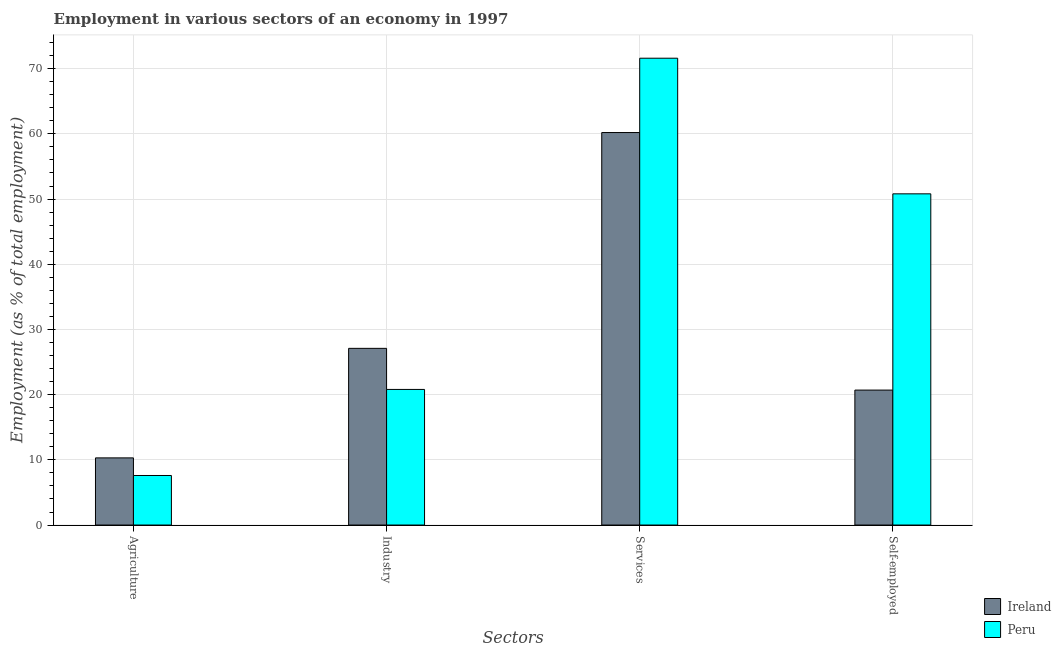Are the number of bars per tick equal to the number of legend labels?
Your answer should be very brief. Yes. How many bars are there on the 4th tick from the left?
Keep it short and to the point. 2. What is the label of the 3rd group of bars from the left?
Your answer should be compact. Services. What is the percentage of workers in agriculture in Peru?
Your answer should be very brief. 7.6. Across all countries, what is the maximum percentage of workers in industry?
Provide a short and direct response. 27.1. Across all countries, what is the minimum percentage of workers in industry?
Offer a terse response. 20.8. In which country was the percentage of workers in services maximum?
Your response must be concise. Peru. What is the total percentage of self employed workers in the graph?
Your answer should be very brief. 71.5. What is the difference between the percentage of self employed workers in Peru and that in Ireland?
Provide a short and direct response. 30.1. What is the difference between the percentage of self employed workers in Peru and the percentage of workers in services in Ireland?
Make the answer very short. -9.4. What is the average percentage of workers in services per country?
Make the answer very short. 65.9. What is the difference between the percentage of workers in services and percentage of workers in agriculture in Ireland?
Provide a succinct answer. 49.9. What is the ratio of the percentage of workers in agriculture in Peru to that in Ireland?
Your response must be concise. 0.74. What is the difference between the highest and the second highest percentage of workers in agriculture?
Ensure brevity in your answer.  2.7. What is the difference between the highest and the lowest percentage of workers in agriculture?
Ensure brevity in your answer.  2.7. What does the 1st bar from the left in Agriculture represents?
Ensure brevity in your answer.  Ireland. What does the 1st bar from the right in Industry represents?
Provide a succinct answer. Peru. How many bars are there?
Ensure brevity in your answer.  8. How many countries are there in the graph?
Your answer should be compact. 2. Are the values on the major ticks of Y-axis written in scientific E-notation?
Make the answer very short. No. Does the graph contain any zero values?
Provide a succinct answer. No. What is the title of the graph?
Give a very brief answer. Employment in various sectors of an economy in 1997. What is the label or title of the X-axis?
Give a very brief answer. Sectors. What is the label or title of the Y-axis?
Provide a short and direct response. Employment (as % of total employment). What is the Employment (as % of total employment) of Ireland in Agriculture?
Your answer should be compact. 10.3. What is the Employment (as % of total employment) in Peru in Agriculture?
Make the answer very short. 7.6. What is the Employment (as % of total employment) of Ireland in Industry?
Provide a succinct answer. 27.1. What is the Employment (as % of total employment) in Peru in Industry?
Offer a very short reply. 20.8. What is the Employment (as % of total employment) of Ireland in Services?
Ensure brevity in your answer.  60.2. What is the Employment (as % of total employment) in Peru in Services?
Your answer should be very brief. 71.6. What is the Employment (as % of total employment) in Ireland in Self-employed?
Keep it short and to the point. 20.7. What is the Employment (as % of total employment) in Peru in Self-employed?
Ensure brevity in your answer.  50.8. Across all Sectors, what is the maximum Employment (as % of total employment) in Ireland?
Your response must be concise. 60.2. Across all Sectors, what is the maximum Employment (as % of total employment) of Peru?
Offer a very short reply. 71.6. Across all Sectors, what is the minimum Employment (as % of total employment) of Ireland?
Your answer should be very brief. 10.3. Across all Sectors, what is the minimum Employment (as % of total employment) in Peru?
Provide a succinct answer. 7.6. What is the total Employment (as % of total employment) of Ireland in the graph?
Make the answer very short. 118.3. What is the total Employment (as % of total employment) of Peru in the graph?
Provide a short and direct response. 150.8. What is the difference between the Employment (as % of total employment) of Ireland in Agriculture and that in Industry?
Provide a succinct answer. -16.8. What is the difference between the Employment (as % of total employment) in Peru in Agriculture and that in Industry?
Your answer should be very brief. -13.2. What is the difference between the Employment (as % of total employment) of Ireland in Agriculture and that in Services?
Your response must be concise. -49.9. What is the difference between the Employment (as % of total employment) in Peru in Agriculture and that in Services?
Your answer should be very brief. -64. What is the difference between the Employment (as % of total employment) in Ireland in Agriculture and that in Self-employed?
Provide a short and direct response. -10.4. What is the difference between the Employment (as % of total employment) of Peru in Agriculture and that in Self-employed?
Offer a very short reply. -43.2. What is the difference between the Employment (as % of total employment) in Ireland in Industry and that in Services?
Your answer should be compact. -33.1. What is the difference between the Employment (as % of total employment) of Peru in Industry and that in Services?
Ensure brevity in your answer.  -50.8. What is the difference between the Employment (as % of total employment) in Peru in Industry and that in Self-employed?
Offer a very short reply. -30. What is the difference between the Employment (as % of total employment) of Ireland in Services and that in Self-employed?
Provide a succinct answer. 39.5. What is the difference between the Employment (as % of total employment) of Peru in Services and that in Self-employed?
Your answer should be very brief. 20.8. What is the difference between the Employment (as % of total employment) in Ireland in Agriculture and the Employment (as % of total employment) in Peru in Services?
Your response must be concise. -61.3. What is the difference between the Employment (as % of total employment) in Ireland in Agriculture and the Employment (as % of total employment) in Peru in Self-employed?
Provide a short and direct response. -40.5. What is the difference between the Employment (as % of total employment) in Ireland in Industry and the Employment (as % of total employment) in Peru in Services?
Your answer should be very brief. -44.5. What is the difference between the Employment (as % of total employment) in Ireland in Industry and the Employment (as % of total employment) in Peru in Self-employed?
Ensure brevity in your answer.  -23.7. What is the difference between the Employment (as % of total employment) of Ireland in Services and the Employment (as % of total employment) of Peru in Self-employed?
Keep it short and to the point. 9.4. What is the average Employment (as % of total employment) of Ireland per Sectors?
Your response must be concise. 29.57. What is the average Employment (as % of total employment) in Peru per Sectors?
Make the answer very short. 37.7. What is the difference between the Employment (as % of total employment) of Ireland and Employment (as % of total employment) of Peru in Industry?
Your response must be concise. 6.3. What is the difference between the Employment (as % of total employment) of Ireland and Employment (as % of total employment) of Peru in Services?
Your response must be concise. -11.4. What is the difference between the Employment (as % of total employment) in Ireland and Employment (as % of total employment) in Peru in Self-employed?
Offer a very short reply. -30.1. What is the ratio of the Employment (as % of total employment) of Ireland in Agriculture to that in Industry?
Provide a succinct answer. 0.38. What is the ratio of the Employment (as % of total employment) of Peru in Agriculture to that in Industry?
Offer a terse response. 0.37. What is the ratio of the Employment (as % of total employment) in Ireland in Agriculture to that in Services?
Keep it short and to the point. 0.17. What is the ratio of the Employment (as % of total employment) in Peru in Agriculture to that in Services?
Make the answer very short. 0.11. What is the ratio of the Employment (as % of total employment) of Ireland in Agriculture to that in Self-employed?
Offer a terse response. 0.5. What is the ratio of the Employment (as % of total employment) of Peru in Agriculture to that in Self-employed?
Ensure brevity in your answer.  0.15. What is the ratio of the Employment (as % of total employment) in Ireland in Industry to that in Services?
Provide a succinct answer. 0.45. What is the ratio of the Employment (as % of total employment) of Peru in Industry to that in Services?
Offer a terse response. 0.29. What is the ratio of the Employment (as % of total employment) of Ireland in Industry to that in Self-employed?
Provide a succinct answer. 1.31. What is the ratio of the Employment (as % of total employment) in Peru in Industry to that in Self-employed?
Offer a terse response. 0.41. What is the ratio of the Employment (as % of total employment) of Ireland in Services to that in Self-employed?
Make the answer very short. 2.91. What is the ratio of the Employment (as % of total employment) of Peru in Services to that in Self-employed?
Give a very brief answer. 1.41. What is the difference between the highest and the second highest Employment (as % of total employment) of Ireland?
Offer a terse response. 33.1. What is the difference between the highest and the second highest Employment (as % of total employment) of Peru?
Provide a succinct answer. 20.8. What is the difference between the highest and the lowest Employment (as % of total employment) of Ireland?
Your answer should be compact. 49.9. What is the difference between the highest and the lowest Employment (as % of total employment) in Peru?
Give a very brief answer. 64. 